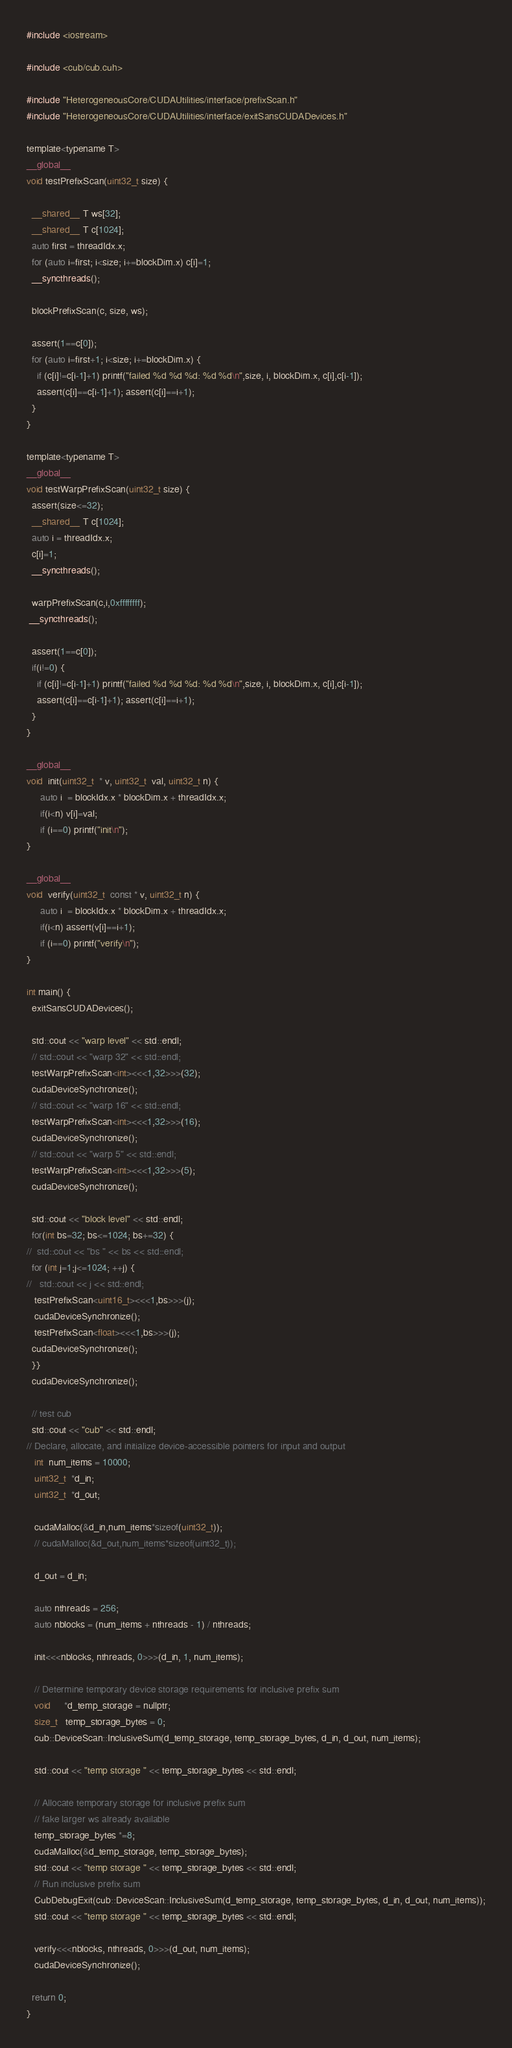<code> <loc_0><loc_0><loc_500><loc_500><_Cuda_>#include <iostream>

#include <cub/cub.cuh> 

#include "HeterogeneousCore/CUDAUtilities/interface/prefixScan.h"
#include "HeterogeneousCore/CUDAUtilities/interface/exitSansCUDADevices.h"

template<typename T>
__global__
void testPrefixScan(uint32_t size) {

  __shared__ T ws[32];
  __shared__ T c[1024];
  auto first = threadIdx.x;
  for (auto i=first; i<size; i+=blockDim.x) c[i]=1;
  __syncthreads();

  blockPrefixScan(c, size, ws);

  assert(1==c[0]);
  for (auto i=first+1; i<size; i+=blockDim.x) {
    if (c[i]!=c[i-1]+1) printf("failed %d %d %d: %d %d\n",size, i, blockDim.x, c[i],c[i-1]);
    assert(c[i]==c[i-1]+1); assert(c[i]==i+1);
  }
}

template<typename T>
__global__
void testWarpPrefixScan(uint32_t size) {
  assert(size<=32);
  __shared__ T c[1024];
  auto i = threadIdx.x;
  c[i]=1;
  __syncthreads();

  warpPrefixScan(c,i,0xffffffff);
 __syncthreads();

  assert(1==c[0]);
  if(i!=0) {
    if (c[i]!=c[i-1]+1) printf("failed %d %d %d: %d %d\n",size, i, blockDim.x, c[i],c[i-1]);
    assert(c[i]==c[i-1]+1); assert(c[i]==i+1);
  }
}

__global__
void  init(uint32_t  * v, uint32_t  val, uint32_t n) {
     auto i  = blockIdx.x * blockDim.x + threadIdx.x;
     if(i<n) v[i]=val;
     if (i==0) printf("init\n");
}

__global__
void  verify(uint32_t  const * v, uint32_t n) {
     auto i  = blockIdx.x * blockDim.x + threadIdx.x;
     if(i<n) assert(v[i]==i+1);
     if (i==0) printf("verify\n");
}

int main() {
  exitSansCUDADevices();

  std::cout << "warp level" << std::endl;
  // std::cout << "warp 32" << std::endl;
  testWarpPrefixScan<int><<<1,32>>>(32);
  cudaDeviceSynchronize();
  // std::cout << "warp 16" << std::endl;
  testWarpPrefixScan<int><<<1,32>>>(16);
  cudaDeviceSynchronize();
  // std::cout << "warp 5" << std::endl;
  testWarpPrefixScan<int><<<1,32>>>(5);
  cudaDeviceSynchronize();

  std::cout << "block level" << std::endl;
  for(int bs=32; bs<=1024; bs+=32) {
//  std::cout << "bs " << bs << std::endl;
  for (int j=1;j<=1024; ++j) {
//   std::cout << j << std::endl;
   testPrefixScan<uint16_t><<<1,bs>>>(j);
   cudaDeviceSynchronize();
   testPrefixScan<float><<<1,bs>>>(j);
  cudaDeviceSynchronize();
  }}
  cudaDeviceSynchronize();

  // test cub
  std::cout << "cub" << std::endl;
// Declare, allocate, and initialize device-accessible pointers for input and output
   int  num_items = 10000;
   uint32_t  *d_in;         
   uint32_t  *d_out;

   cudaMalloc(&d_in,num_items*sizeof(uint32_t));
   // cudaMalloc(&d_out,num_items*sizeof(uint32_t));

   d_out = d_in;
  
   auto nthreads = 256;
   auto nblocks = (num_items + nthreads - 1) / nthreads;

   init<<<nblocks, nthreads, 0>>>(d_in, 1, num_items);

   // Determine temporary device storage requirements for inclusive prefix sum
   void     *d_temp_storage = nullptr;
   size_t   temp_storage_bytes = 0;
   cub::DeviceScan::InclusiveSum(d_temp_storage, temp_storage_bytes, d_in, d_out, num_items);

   std::cout << "temp storage " << temp_storage_bytes << std::endl;

   // Allocate temporary storage for inclusive prefix sum
   // fake larger ws already available
   temp_storage_bytes *=8;
   cudaMalloc(&d_temp_storage, temp_storage_bytes);
   std::cout << "temp storage " << temp_storage_bytes << std::endl;
   // Run inclusive prefix sum
   CubDebugExit(cub::DeviceScan::InclusiveSum(d_temp_storage, temp_storage_bytes, d_in, d_out, num_items));
   std::cout << "temp storage " << temp_storage_bytes << std::endl;

   verify<<<nblocks, nthreads, 0>>>(d_out, num_items);
   cudaDeviceSynchronize();

  return 0;
}
</code> 